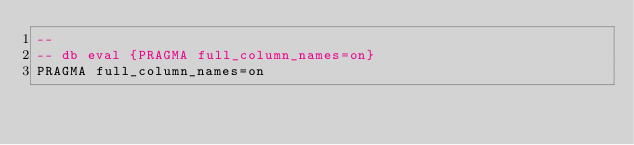Convert code to text. <code><loc_0><loc_0><loc_500><loc_500><_SQL_>-- 
-- db eval {PRAGMA full_column_names=on}
PRAGMA full_column_names=on</code> 